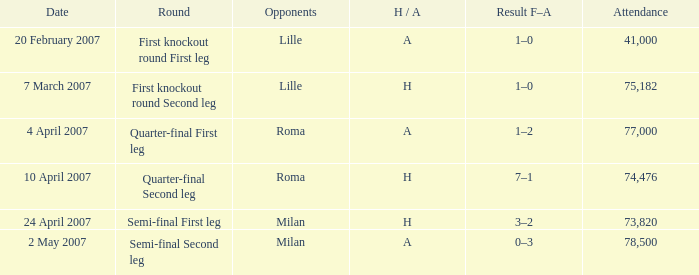What is the H/A for 20 february 2007? A. 